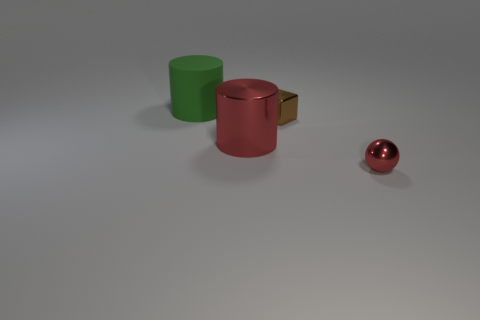What number of balls are large blue metallic things or brown objects?
Offer a very short reply. 0. There is a small ball that is made of the same material as the big red cylinder; what color is it?
Give a very brief answer. Red. Do the tiny brown cube and the red thing left of the shiny ball have the same material?
Your answer should be very brief. Yes. What number of things are either shiny objects or big green cylinders?
Offer a very short reply. 4. What material is the cylinder that is the same color as the ball?
Your response must be concise. Metal. Is there a tiny brown metallic object that has the same shape as the big metallic thing?
Give a very brief answer. No. How many green matte cylinders are behind the brown metallic block?
Offer a very short reply. 1. What material is the large cylinder that is to the right of the cylinder that is behind the brown metal cube?
Your answer should be compact. Metal. There is a green object that is the same size as the red cylinder; what is it made of?
Provide a short and direct response. Rubber. Is there a shiny object of the same size as the brown cube?
Your answer should be compact. Yes. 